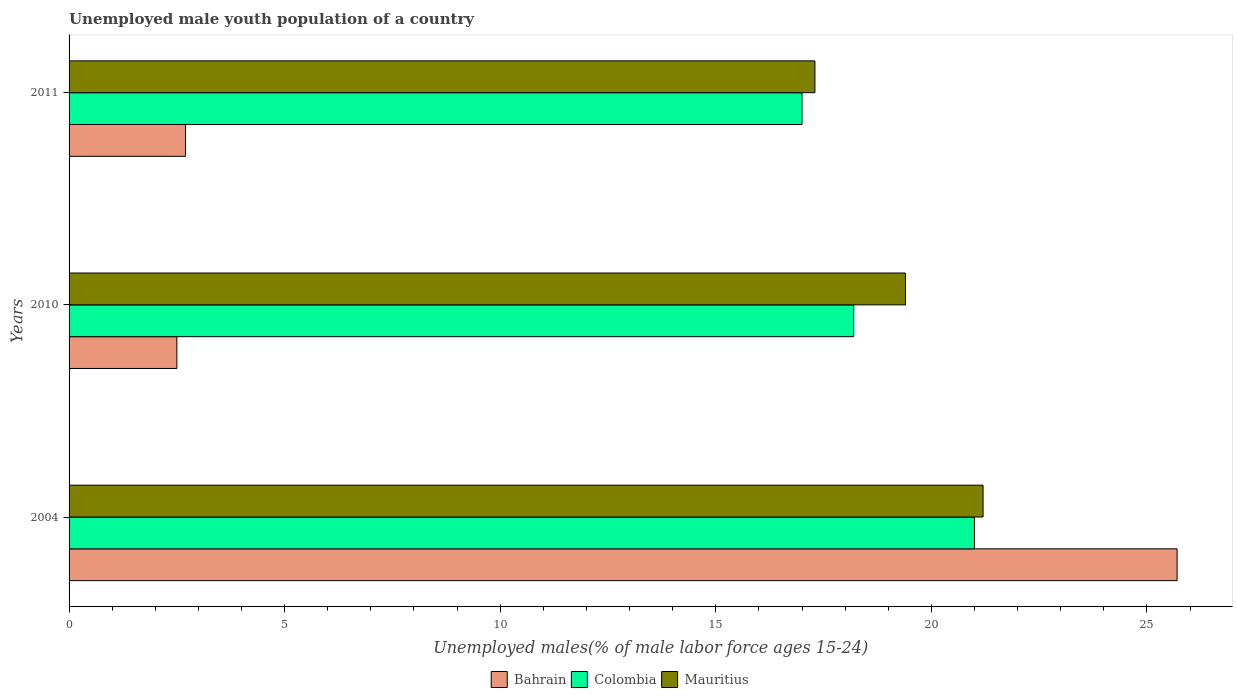How many different coloured bars are there?
Provide a short and direct response. 3. Are the number of bars per tick equal to the number of legend labels?
Ensure brevity in your answer.  Yes. Are the number of bars on each tick of the Y-axis equal?
Provide a succinct answer. Yes. What is the label of the 2nd group of bars from the top?
Offer a terse response. 2010. In how many cases, is the number of bars for a given year not equal to the number of legend labels?
Give a very brief answer. 0. What is the percentage of unemployed male youth population in Mauritius in 2011?
Your answer should be very brief. 17.3. Across all years, what is the maximum percentage of unemployed male youth population in Mauritius?
Give a very brief answer. 21.2. Across all years, what is the minimum percentage of unemployed male youth population in Bahrain?
Keep it short and to the point. 2.5. In which year was the percentage of unemployed male youth population in Bahrain minimum?
Give a very brief answer. 2010. What is the total percentage of unemployed male youth population in Colombia in the graph?
Your response must be concise. 56.2. What is the difference between the percentage of unemployed male youth population in Colombia in 2004 and that in 2011?
Your answer should be compact. 4. What is the difference between the percentage of unemployed male youth population in Mauritius in 2004 and the percentage of unemployed male youth population in Colombia in 2010?
Keep it short and to the point. 3. What is the average percentage of unemployed male youth population in Bahrain per year?
Make the answer very short. 10.3. In the year 2011, what is the difference between the percentage of unemployed male youth population in Mauritius and percentage of unemployed male youth population in Colombia?
Ensure brevity in your answer.  0.3. What is the ratio of the percentage of unemployed male youth population in Colombia in 2010 to that in 2011?
Make the answer very short. 1.07. Is the difference between the percentage of unemployed male youth population in Mauritius in 2010 and 2011 greater than the difference between the percentage of unemployed male youth population in Colombia in 2010 and 2011?
Ensure brevity in your answer.  Yes. What is the difference between the highest and the second highest percentage of unemployed male youth population in Bahrain?
Your answer should be very brief. 23. What is the difference between the highest and the lowest percentage of unemployed male youth population in Colombia?
Offer a terse response. 4. Is the sum of the percentage of unemployed male youth population in Colombia in 2010 and 2011 greater than the maximum percentage of unemployed male youth population in Bahrain across all years?
Ensure brevity in your answer.  Yes. What does the 1st bar from the bottom in 2010 represents?
Provide a short and direct response. Bahrain. Is it the case that in every year, the sum of the percentage of unemployed male youth population in Mauritius and percentage of unemployed male youth population in Bahrain is greater than the percentage of unemployed male youth population in Colombia?
Offer a very short reply. Yes. How many bars are there?
Your response must be concise. 9. How many years are there in the graph?
Your answer should be compact. 3. Where does the legend appear in the graph?
Offer a terse response. Bottom center. How many legend labels are there?
Your answer should be compact. 3. What is the title of the graph?
Offer a terse response. Unemployed male youth population of a country. What is the label or title of the X-axis?
Offer a very short reply. Unemployed males(% of male labor force ages 15-24). What is the label or title of the Y-axis?
Offer a very short reply. Years. What is the Unemployed males(% of male labor force ages 15-24) of Bahrain in 2004?
Offer a terse response. 25.7. What is the Unemployed males(% of male labor force ages 15-24) in Mauritius in 2004?
Offer a very short reply. 21.2. What is the Unemployed males(% of male labor force ages 15-24) of Colombia in 2010?
Make the answer very short. 18.2. What is the Unemployed males(% of male labor force ages 15-24) in Mauritius in 2010?
Offer a very short reply. 19.4. What is the Unemployed males(% of male labor force ages 15-24) of Bahrain in 2011?
Make the answer very short. 2.7. What is the Unemployed males(% of male labor force ages 15-24) in Mauritius in 2011?
Provide a succinct answer. 17.3. Across all years, what is the maximum Unemployed males(% of male labor force ages 15-24) in Bahrain?
Provide a succinct answer. 25.7. Across all years, what is the maximum Unemployed males(% of male labor force ages 15-24) in Mauritius?
Give a very brief answer. 21.2. Across all years, what is the minimum Unemployed males(% of male labor force ages 15-24) in Mauritius?
Your response must be concise. 17.3. What is the total Unemployed males(% of male labor force ages 15-24) in Bahrain in the graph?
Offer a terse response. 30.9. What is the total Unemployed males(% of male labor force ages 15-24) in Colombia in the graph?
Your response must be concise. 56.2. What is the total Unemployed males(% of male labor force ages 15-24) in Mauritius in the graph?
Offer a very short reply. 57.9. What is the difference between the Unemployed males(% of male labor force ages 15-24) of Bahrain in 2004 and that in 2010?
Your response must be concise. 23.2. What is the difference between the Unemployed males(% of male labor force ages 15-24) of Colombia in 2004 and that in 2010?
Provide a short and direct response. 2.8. What is the difference between the Unemployed males(% of male labor force ages 15-24) of Mauritius in 2004 and that in 2010?
Give a very brief answer. 1.8. What is the difference between the Unemployed males(% of male labor force ages 15-24) of Bahrain in 2004 and that in 2011?
Make the answer very short. 23. What is the difference between the Unemployed males(% of male labor force ages 15-24) in Colombia in 2004 and that in 2011?
Your response must be concise. 4. What is the difference between the Unemployed males(% of male labor force ages 15-24) in Mauritius in 2004 and that in 2011?
Offer a very short reply. 3.9. What is the difference between the Unemployed males(% of male labor force ages 15-24) of Bahrain in 2010 and that in 2011?
Make the answer very short. -0.2. What is the difference between the Unemployed males(% of male labor force ages 15-24) in Bahrain in 2004 and the Unemployed males(% of male labor force ages 15-24) in Colombia in 2010?
Provide a short and direct response. 7.5. What is the difference between the Unemployed males(% of male labor force ages 15-24) of Colombia in 2004 and the Unemployed males(% of male labor force ages 15-24) of Mauritius in 2010?
Keep it short and to the point. 1.6. What is the difference between the Unemployed males(% of male labor force ages 15-24) in Bahrain in 2004 and the Unemployed males(% of male labor force ages 15-24) in Colombia in 2011?
Offer a terse response. 8.7. What is the difference between the Unemployed males(% of male labor force ages 15-24) in Bahrain in 2004 and the Unemployed males(% of male labor force ages 15-24) in Mauritius in 2011?
Offer a very short reply. 8.4. What is the difference between the Unemployed males(% of male labor force ages 15-24) of Bahrain in 2010 and the Unemployed males(% of male labor force ages 15-24) of Colombia in 2011?
Offer a very short reply. -14.5. What is the difference between the Unemployed males(% of male labor force ages 15-24) in Bahrain in 2010 and the Unemployed males(% of male labor force ages 15-24) in Mauritius in 2011?
Offer a very short reply. -14.8. What is the difference between the Unemployed males(% of male labor force ages 15-24) of Colombia in 2010 and the Unemployed males(% of male labor force ages 15-24) of Mauritius in 2011?
Your response must be concise. 0.9. What is the average Unemployed males(% of male labor force ages 15-24) of Bahrain per year?
Offer a very short reply. 10.3. What is the average Unemployed males(% of male labor force ages 15-24) of Colombia per year?
Keep it short and to the point. 18.73. What is the average Unemployed males(% of male labor force ages 15-24) of Mauritius per year?
Your answer should be very brief. 19.3. In the year 2004, what is the difference between the Unemployed males(% of male labor force ages 15-24) in Bahrain and Unemployed males(% of male labor force ages 15-24) in Colombia?
Provide a succinct answer. 4.7. In the year 2004, what is the difference between the Unemployed males(% of male labor force ages 15-24) of Bahrain and Unemployed males(% of male labor force ages 15-24) of Mauritius?
Provide a succinct answer. 4.5. In the year 2004, what is the difference between the Unemployed males(% of male labor force ages 15-24) in Colombia and Unemployed males(% of male labor force ages 15-24) in Mauritius?
Give a very brief answer. -0.2. In the year 2010, what is the difference between the Unemployed males(% of male labor force ages 15-24) of Bahrain and Unemployed males(% of male labor force ages 15-24) of Colombia?
Provide a short and direct response. -15.7. In the year 2010, what is the difference between the Unemployed males(% of male labor force ages 15-24) in Bahrain and Unemployed males(% of male labor force ages 15-24) in Mauritius?
Offer a terse response. -16.9. In the year 2010, what is the difference between the Unemployed males(% of male labor force ages 15-24) in Colombia and Unemployed males(% of male labor force ages 15-24) in Mauritius?
Offer a very short reply. -1.2. In the year 2011, what is the difference between the Unemployed males(% of male labor force ages 15-24) in Bahrain and Unemployed males(% of male labor force ages 15-24) in Colombia?
Your answer should be very brief. -14.3. In the year 2011, what is the difference between the Unemployed males(% of male labor force ages 15-24) in Bahrain and Unemployed males(% of male labor force ages 15-24) in Mauritius?
Your answer should be compact. -14.6. In the year 2011, what is the difference between the Unemployed males(% of male labor force ages 15-24) of Colombia and Unemployed males(% of male labor force ages 15-24) of Mauritius?
Provide a succinct answer. -0.3. What is the ratio of the Unemployed males(% of male labor force ages 15-24) of Bahrain in 2004 to that in 2010?
Provide a short and direct response. 10.28. What is the ratio of the Unemployed males(% of male labor force ages 15-24) of Colombia in 2004 to that in 2010?
Give a very brief answer. 1.15. What is the ratio of the Unemployed males(% of male labor force ages 15-24) of Mauritius in 2004 to that in 2010?
Give a very brief answer. 1.09. What is the ratio of the Unemployed males(% of male labor force ages 15-24) in Bahrain in 2004 to that in 2011?
Your answer should be very brief. 9.52. What is the ratio of the Unemployed males(% of male labor force ages 15-24) of Colombia in 2004 to that in 2011?
Make the answer very short. 1.24. What is the ratio of the Unemployed males(% of male labor force ages 15-24) in Mauritius in 2004 to that in 2011?
Provide a succinct answer. 1.23. What is the ratio of the Unemployed males(% of male labor force ages 15-24) in Bahrain in 2010 to that in 2011?
Your answer should be compact. 0.93. What is the ratio of the Unemployed males(% of male labor force ages 15-24) of Colombia in 2010 to that in 2011?
Provide a succinct answer. 1.07. What is the ratio of the Unemployed males(% of male labor force ages 15-24) of Mauritius in 2010 to that in 2011?
Your answer should be compact. 1.12. What is the difference between the highest and the lowest Unemployed males(% of male labor force ages 15-24) of Bahrain?
Keep it short and to the point. 23.2. 